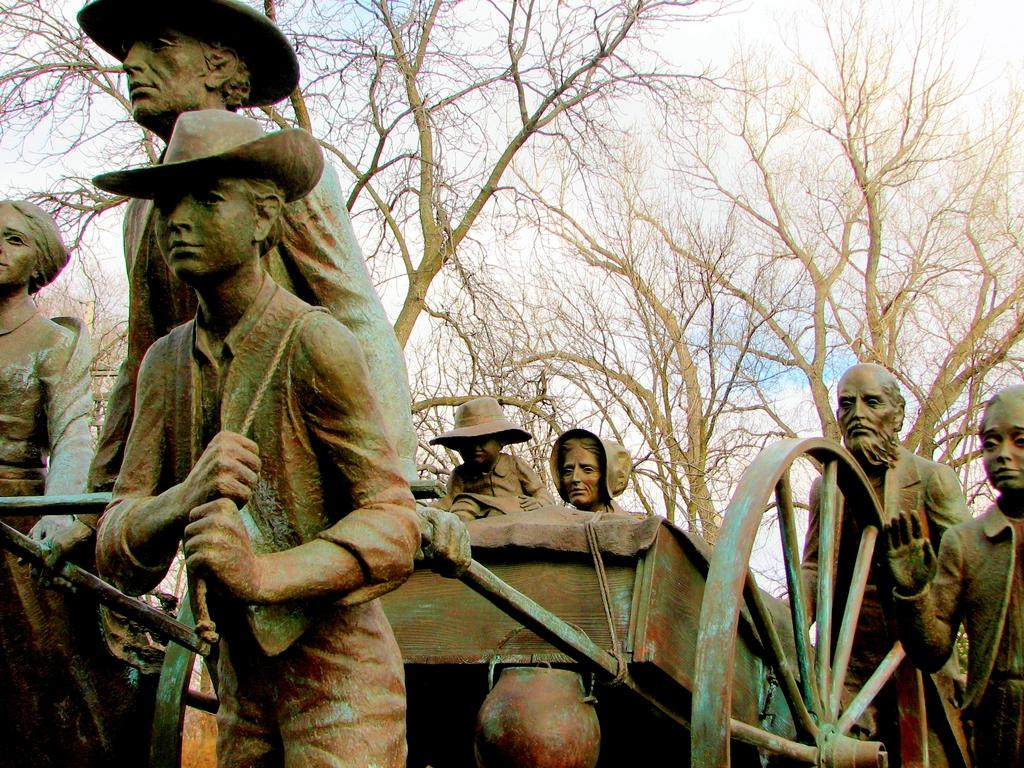What type of objects can be seen in the image? There are statues in the image. What is located at the bottom of the image? There is a moving cart at the bottom of the image. What can be seen in the distance in the image? There are trees in the background of the image. What color is the paste used to create the statues in the image? There is no mention of paste or its color in the image, as the statues are likely made of a different material. 